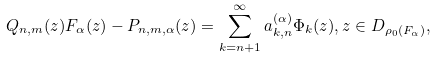<formula> <loc_0><loc_0><loc_500><loc_500>Q _ { n , m } ( z ) F _ { \alpha } ( z ) - P _ { n , m , \alpha } ( z ) = \sum _ { k = n + 1 } ^ { \infty } a _ { k , n } ^ { ( \alpha ) } \Phi _ { k } ( z ) , z \in D _ { \rho _ { 0 } ( F _ { \alpha } ) } ,</formula> 